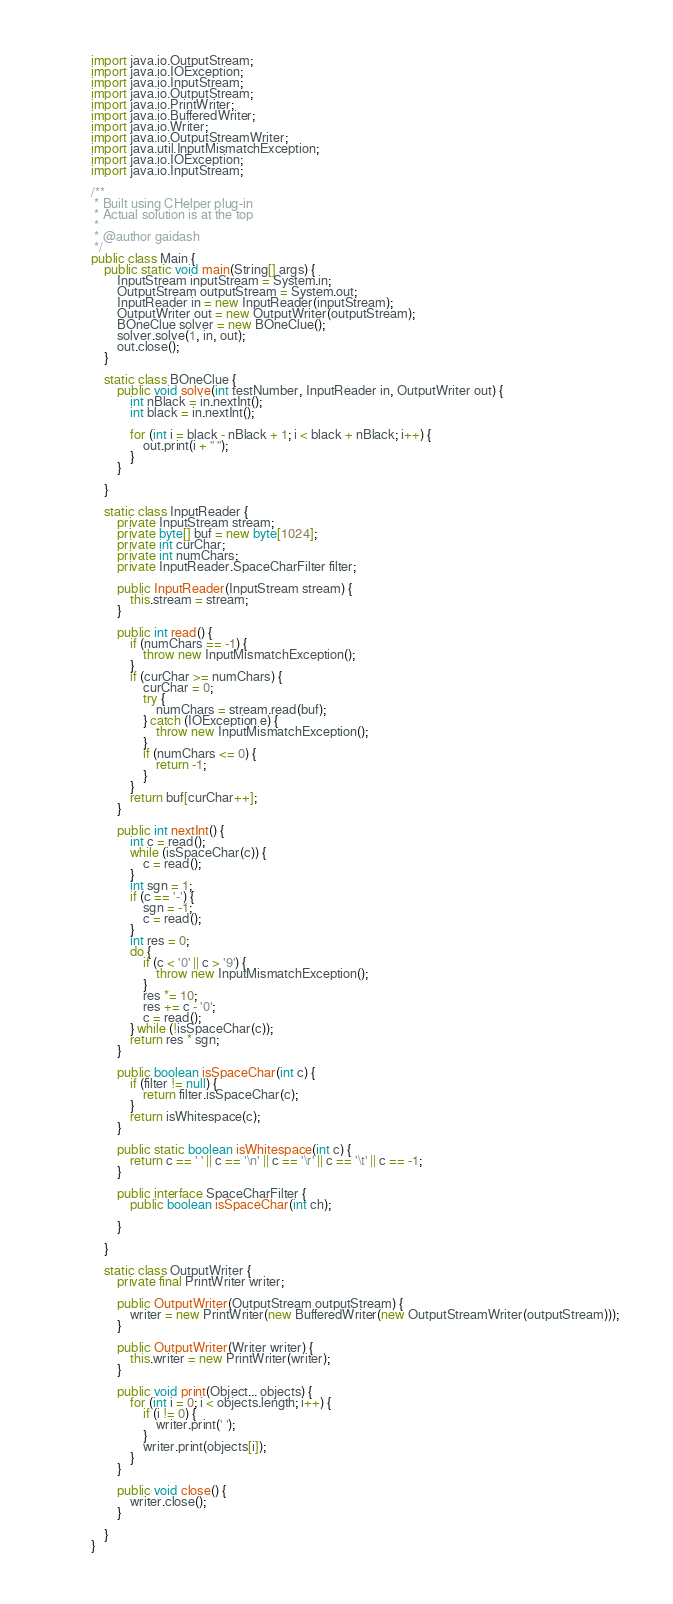Convert code to text. <code><loc_0><loc_0><loc_500><loc_500><_Java_>import java.io.OutputStream;
import java.io.IOException;
import java.io.InputStream;
import java.io.OutputStream;
import java.io.PrintWriter;
import java.io.BufferedWriter;
import java.io.Writer;
import java.io.OutputStreamWriter;
import java.util.InputMismatchException;
import java.io.IOException;
import java.io.InputStream;

/**
 * Built using CHelper plug-in
 * Actual solution is at the top
 *
 * @author gaidash
 */
public class Main {
    public static void main(String[] args) {
        InputStream inputStream = System.in;
        OutputStream outputStream = System.out;
        InputReader in = new InputReader(inputStream);
        OutputWriter out = new OutputWriter(outputStream);
        BOneClue solver = new BOneClue();
        solver.solve(1, in, out);
        out.close();
    }

    static class BOneClue {
        public void solve(int testNumber, InputReader in, OutputWriter out) {
            int nBlack = in.nextInt();
            int black = in.nextInt();

            for (int i = black - nBlack + 1; i < black + nBlack; i++) {
                out.print(i + " ");
            }
        }

    }

    static class InputReader {
        private InputStream stream;
        private byte[] buf = new byte[1024];
        private int curChar;
        private int numChars;
        private InputReader.SpaceCharFilter filter;

        public InputReader(InputStream stream) {
            this.stream = stream;
        }

        public int read() {
            if (numChars == -1) {
                throw new InputMismatchException();
            }
            if (curChar >= numChars) {
                curChar = 0;
                try {
                    numChars = stream.read(buf);
                } catch (IOException e) {
                    throw new InputMismatchException();
                }
                if (numChars <= 0) {
                    return -1;
                }
            }
            return buf[curChar++];
        }

        public int nextInt() {
            int c = read();
            while (isSpaceChar(c)) {
                c = read();
            }
            int sgn = 1;
            if (c == '-') {
                sgn = -1;
                c = read();
            }
            int res = 0;
            do {
                if (c < '0' || c > '9') {
                    throw new InputMismatchException();
                }
                res *= 10;
                res += c - '0';
                c = read();
            } while (!isSpaceChar(c));
            return res * sgn;
        }

        public boolean isSpaceChar(int c) {
            if (filter != null) {
                return filter.isSpaceChar(c);
            }
            return isWhitespace(c);
        }

        public static boolean isWhitespace(int c) {
            return c == ' ' || c == '\n' || c == '\r' || c == '\t' || c == -1;
        }

        public interface SpaceCharFilter {
            public boolean isSpaceChar(int ch);

        }

    }

    static class OutputWriter {
        private final PrintWriter writer;

        public OutputWriter(OutputStream outputStream) {
            writer = new PrintWriter(new BufferedWriter(new OutputStreamWriter(outputStream)));
        }

        public OutputWriter(Writer writer) {
            this.writer = new PrintWriter(writer);
        }

        public void print(Object... objects) {
            for (int i = 0; i < objects.length; i++) {
                if (i != 0) {
                    writer.print(' ');
                }
                writer.print(objects[i]);
            }
        }

        public void close() {
            writer.close();
        }

    }
}

</code> 